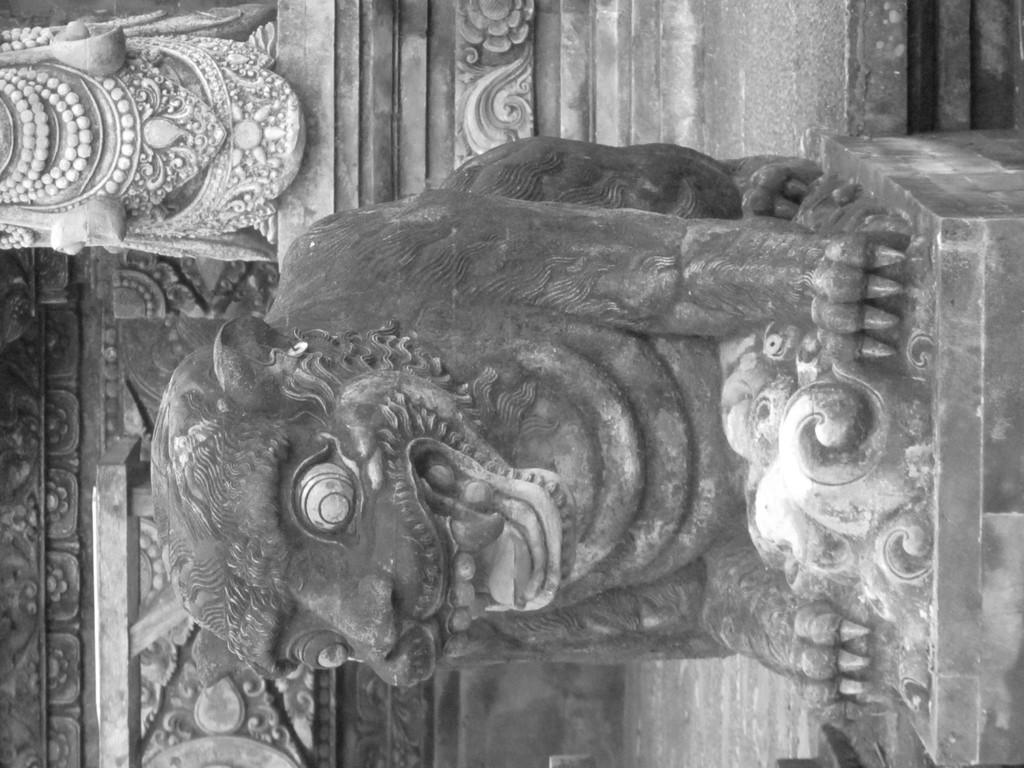What is present in the image that serves as a background or barrier? There is a wall in the image. What activity is being performed by the people in the image? There are sculptors in the image, so they are likely creating or working on a sculpture. What type of sculpture can be seen in the image? There is a sculpture of an animal in the image. What type of letters are being used to create the animal sculpture in the image? There are no letters present in the image, and the animal sculpture is not made of letters. Can you see any powder or feathers on the sculptors while they work on the animal sculpture in the image? There is no mention of powder or feathers in the image, so we cannot determine if they are present or not. 